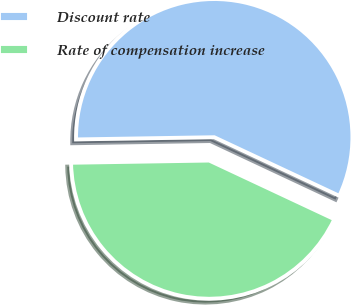Convert chart. <chart><loc_0><loc_0><loc_500><loc_500><pie_chart><fcel>Discount rate<fcel>Rate of compensation increase<nl><fcel>57.23%<fcel>42.77%<nl></chart> 